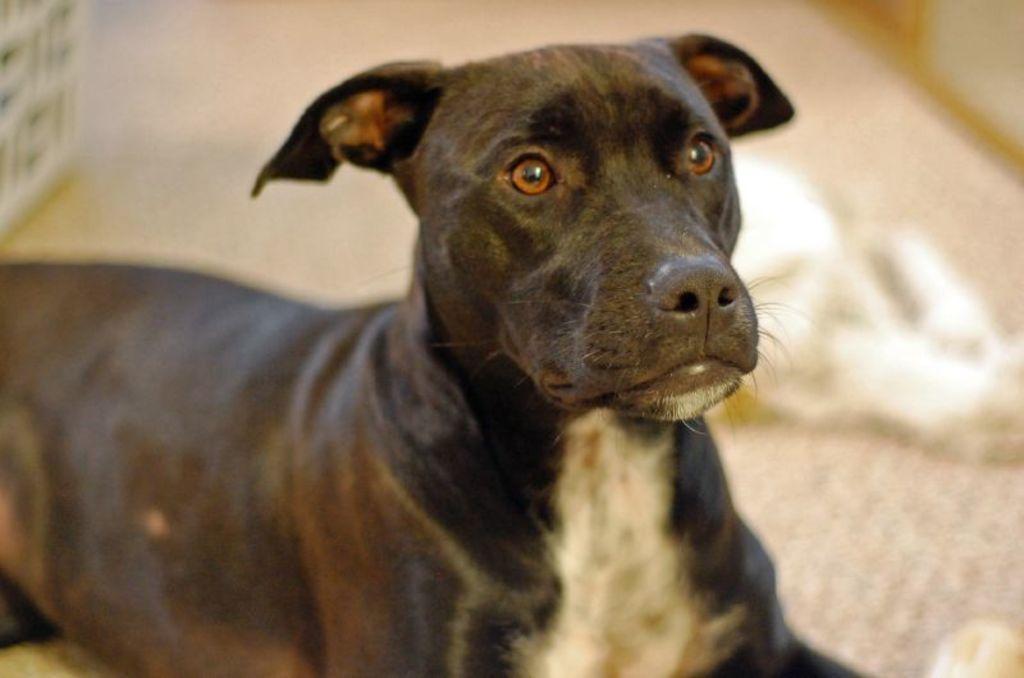What animal is in the image? There is a dog in the image. Where is the dog located in the image? The dog is in the center of the image. What color is the dog? The dog is black in color. What type of wave can be seen crashing on the street in the image? There is no wave or street present in the image; it features a dog. What kind of trouble is the dog causing in the image? There is no indication of trouble in the image; the dog is simply present in the image. 